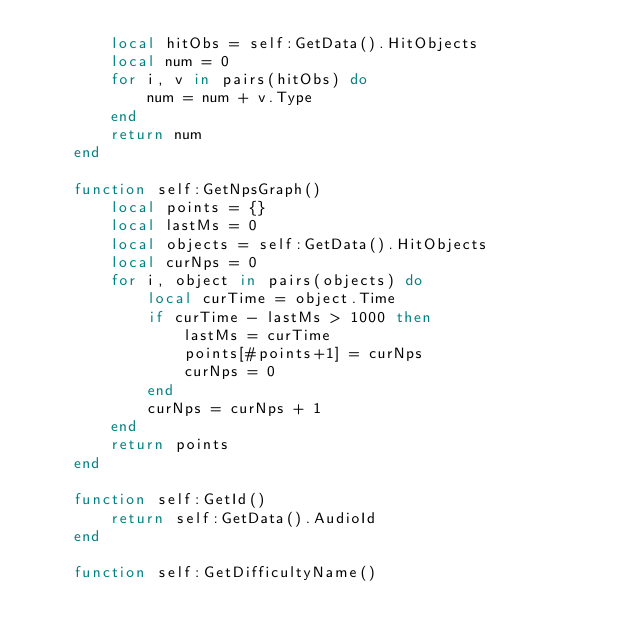<code> <loc_0><loc_0><loc_500><loc_500><_Lua_>		local hitObs = self:GetData().HitObjects
		local num = 0
		for i, v in pairs(hitObs) do
			num = num + v.Type
		end
		return num
	end

	function self:GetNpsGraph()
		local points = {}
		local lastMs = 0
		local objects = self:GetData().HitObjects
		local curNps = 0
		for i, object in pairs(objects) do
			local curTime = object.Time
			if curTime - lastMs > 1000 then
				lastMs = curTime
				points[#points+1] = curNps
				curNps = 0
			end
			curNps = curNps + 1
		end
		return points
	end
	
	function self:GetId()
		return self:GetData().AudioId
	end
	
	function self:GetDifficultyName()</code> 